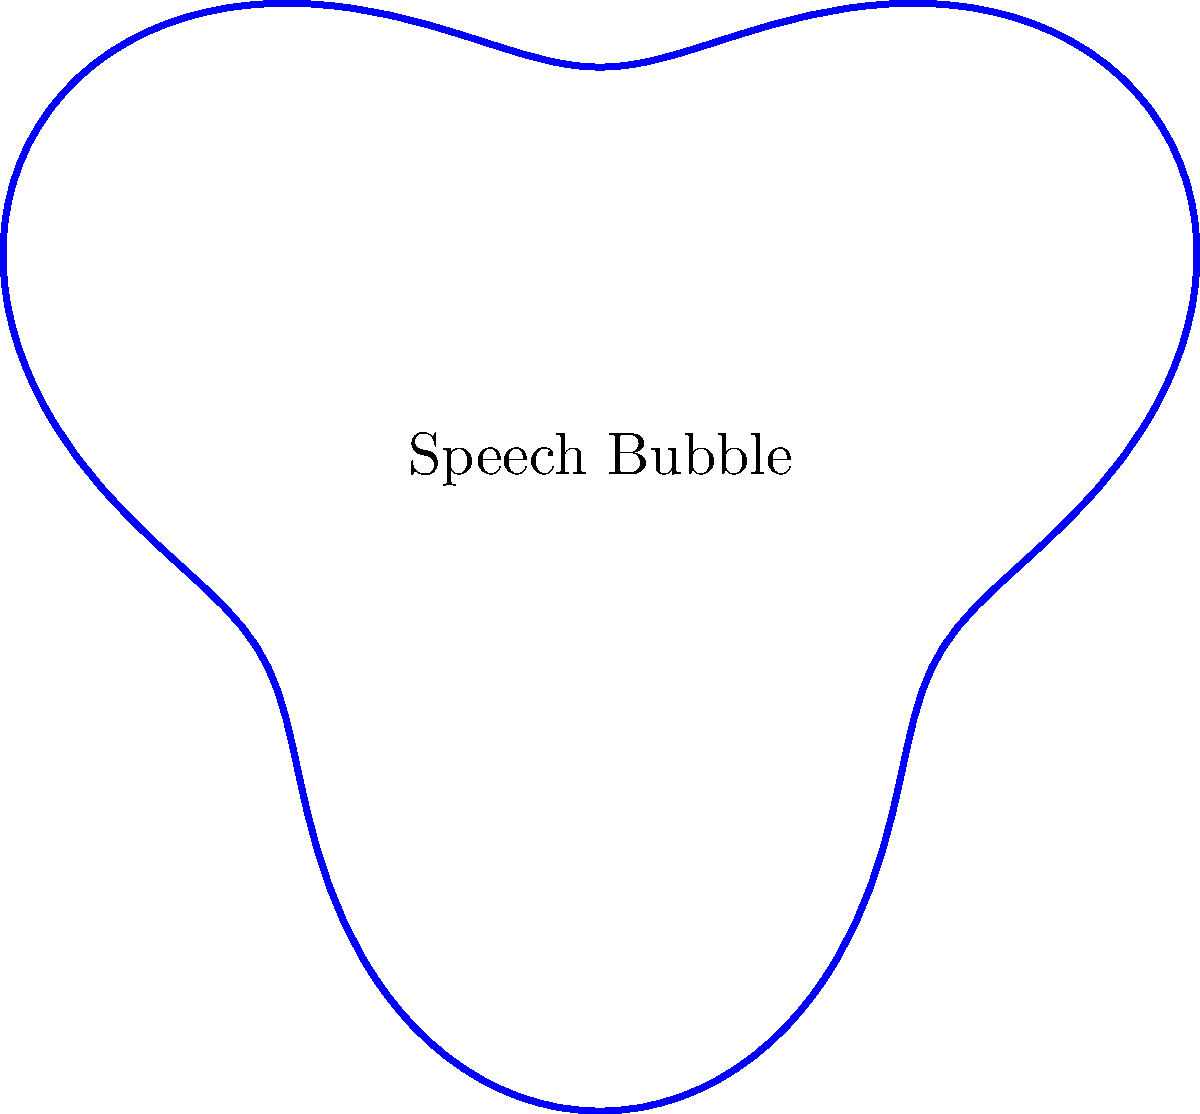As a master of comic illustration, you're tasked with creating a unique circular speech bubble using polar equations. The radius of the bubble varies according to the equation $r(\theta) = 2 + 0.5\sin(3\theta)$. What is the maximum radius of this speech bubble? To find the maximum radius of the speech bubble, we need to analyze the given polar equation:

1) The equation is $r(\theta) = 2 + 0.5\sin(3\theta)$

2) The constant term 2 represents the base radius of the circle.

3) The term $0.5\sin(3\theta)$ causes the radius to oscillate around this base value.

4) The amplitude of this oscillation is 0.5.

5) The maximum value of sine is 1, which occurs when its argument is $\frac{\pi}{2}$ (or odd multiples of it).

6) Therefore, the maximum radius will occur when $0.5\sin(3\theta) = 0.5$

7) The maximum radius will be: $2 + 0.5 = 2.5$

This creates a speech bubble that undulates between a minimum radius of 1.5 and a maximum radius of 2.5, perfect for adding visual interest to your comic panels.
Answer: 2.5 